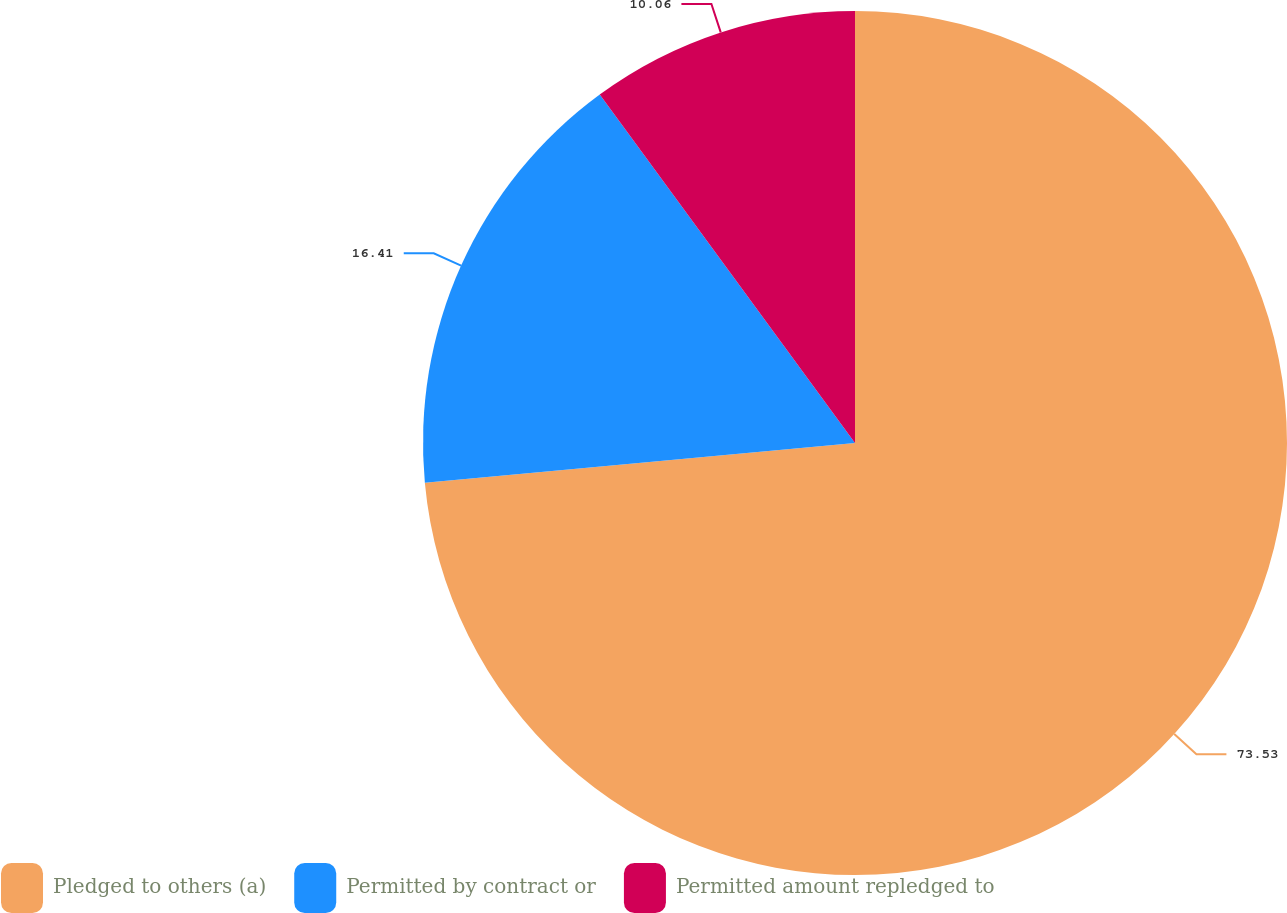Convert chart. <chart><loc_0><loc_0><loc_500><loc_500><pie_chart><fcel>Pledged to others (a)<fcel>Permitted by contract or<fcel>Permitted amount repledged to<nl><fcel>73.53%<fcel>16.41%<fcel>10.06%<nl></chart> 